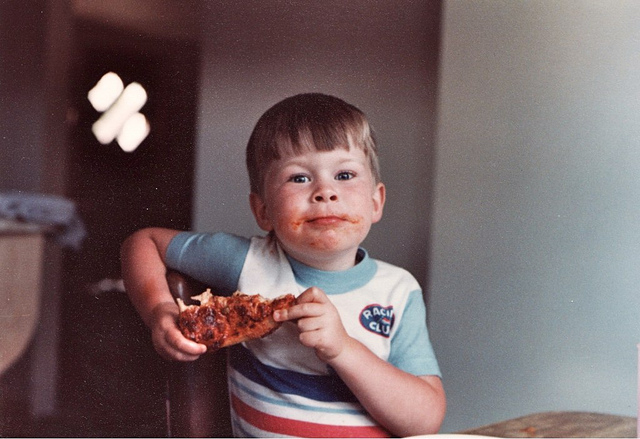Extract all visible text content from this image. RACI CLU 